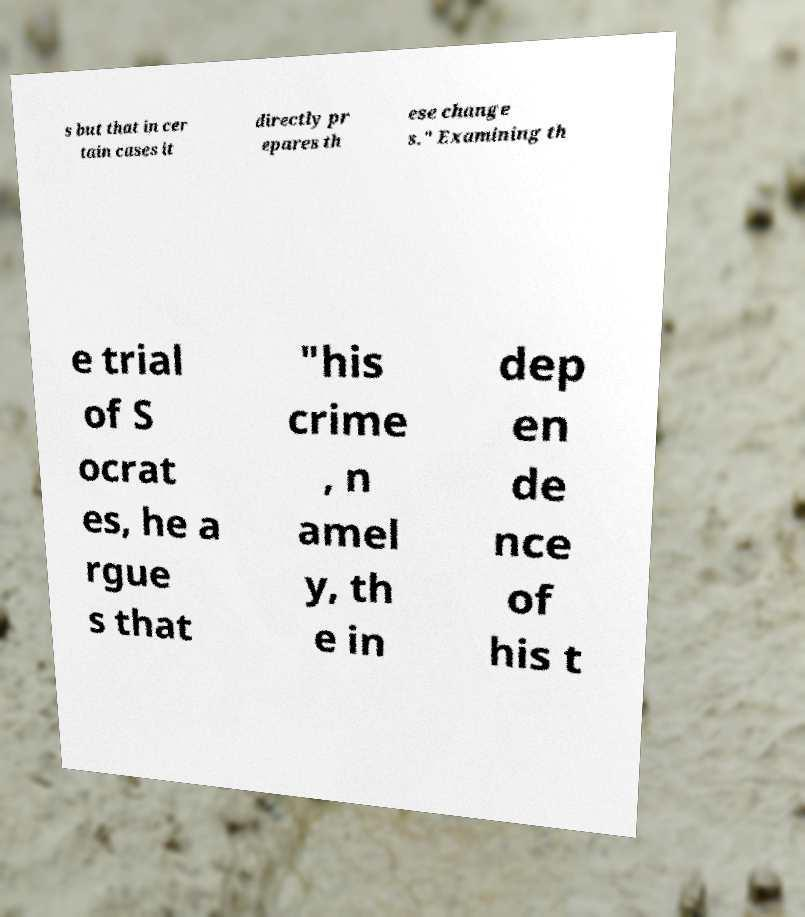Could you extract and type out the text from this image? s but that in cer tain cases it directly pr epares th ese change s." Examining th e trial of S ocrat es, he a rgue s that "his crime , n amel y, th e in dep en de nce of his t 